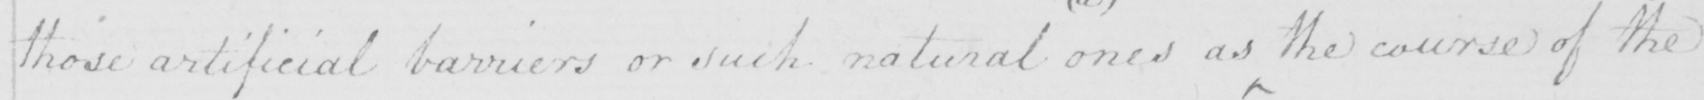Please transcribe the handwritten text in this image. those artificial barriers or such natural  ( a )  ones as the course of the 